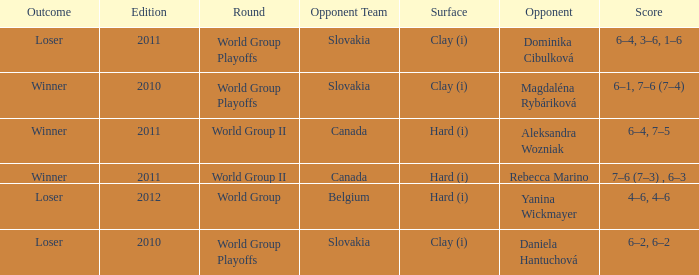What was the score when the opponent was Dominika Cibulková? 6–4, 3–6, 1–6. 